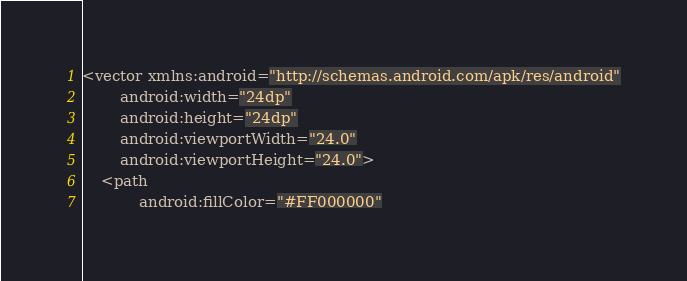Convert code to text. <code><loc_0><loc_0><loc_500><loc_500><_XML_><vector xmlns:android="http://schemas.android.com/apk/res/android"
        android:width="24dp"
        android:height="24dp"
        android:viewportWidth="24.0"
        android:viewportHeight="24.0">
    <path
            android:fillColor="#FF000000"</code> 